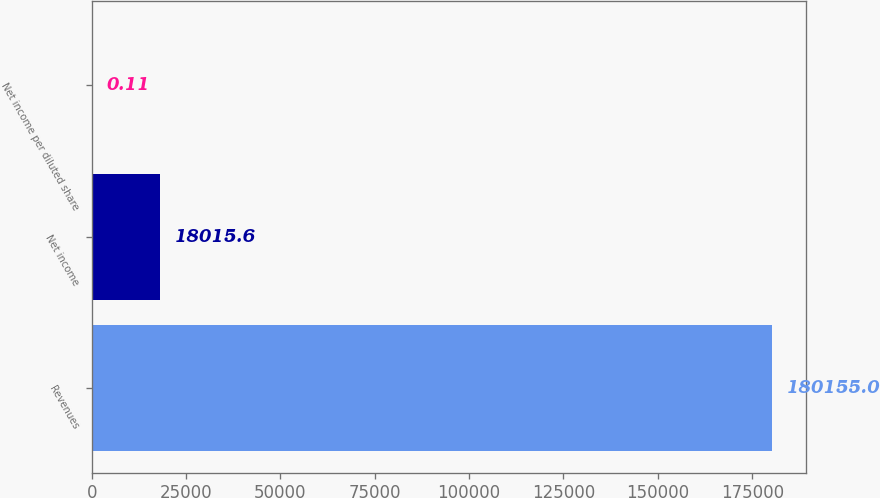<chart> <loc_0><loc_0><loc_500><loc_500><bar_chart><fcel>Revenues<fcel>Net income<fcel>Net income per diluted share<nl><fcel>180155<fcel>18015.6<fcel>0.11<nl></chart> 